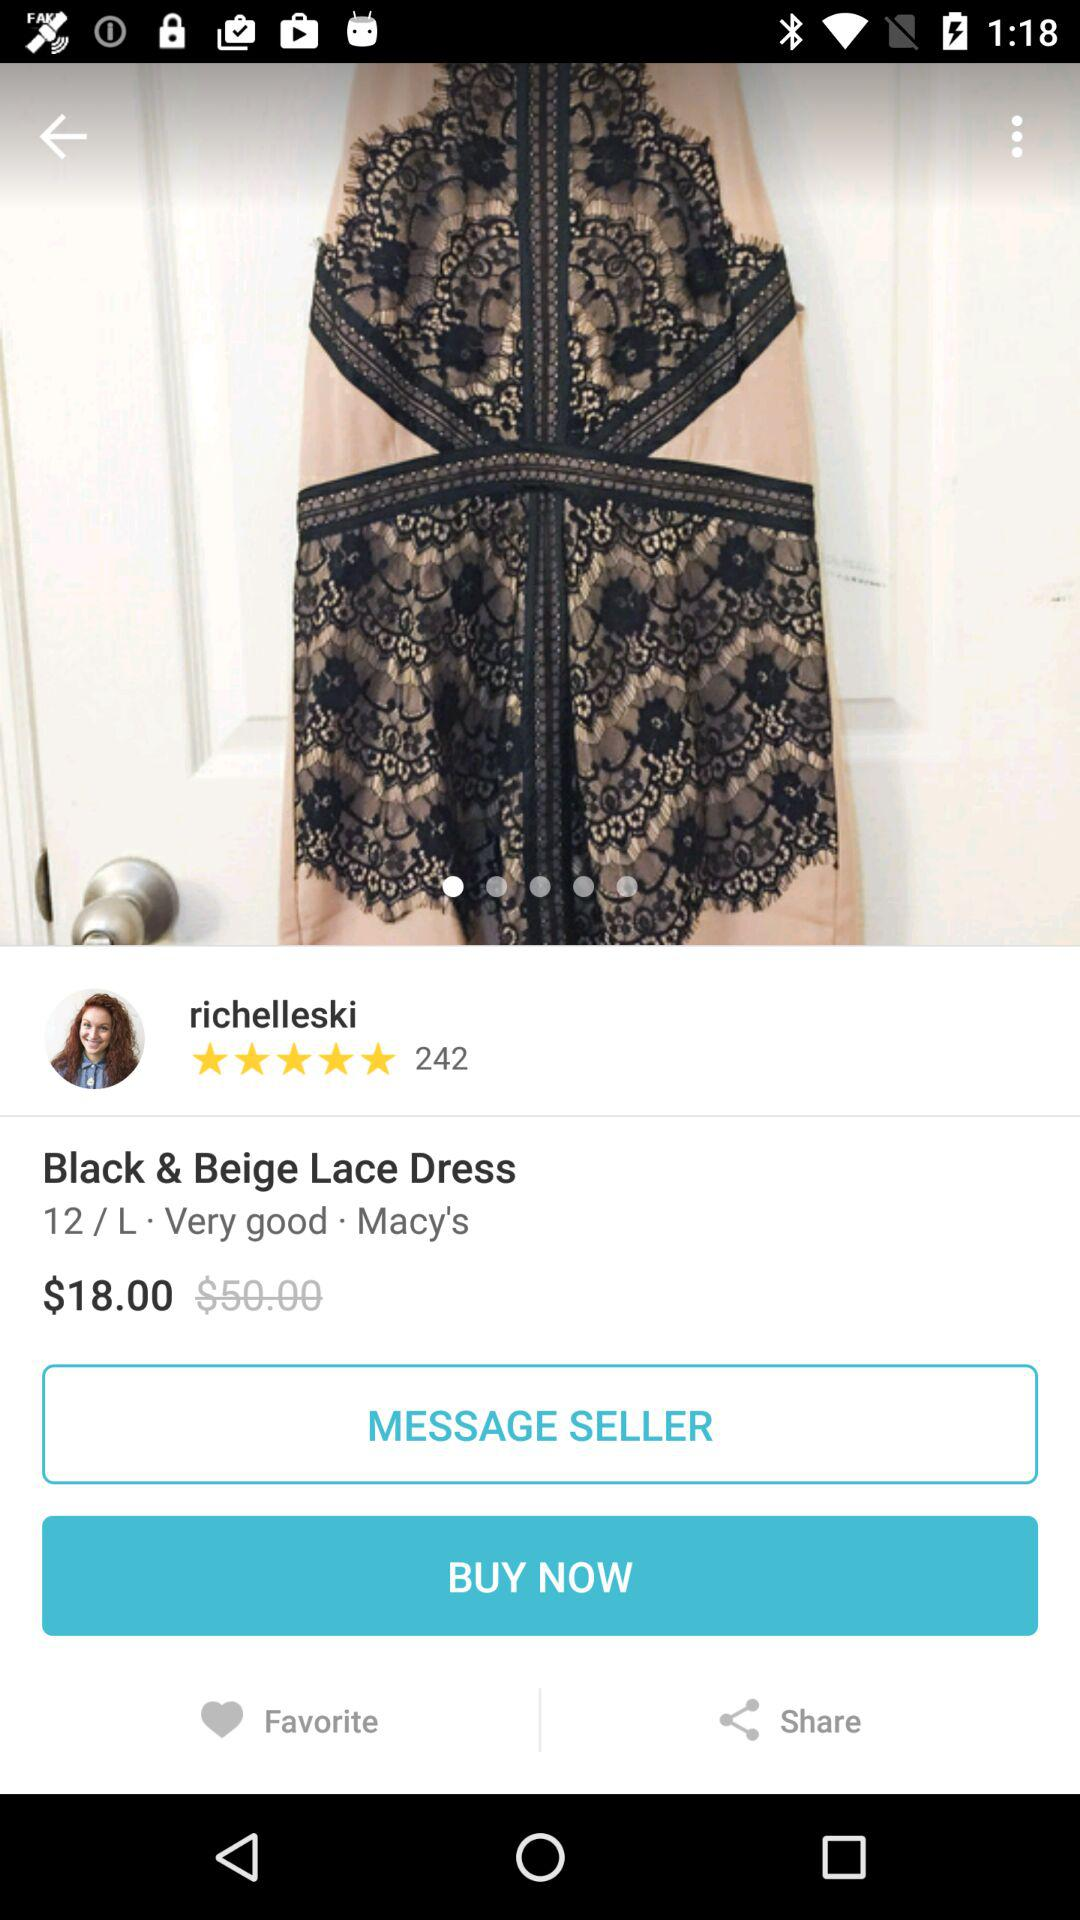What are the ratings of dress? The rating is 5 stars. 